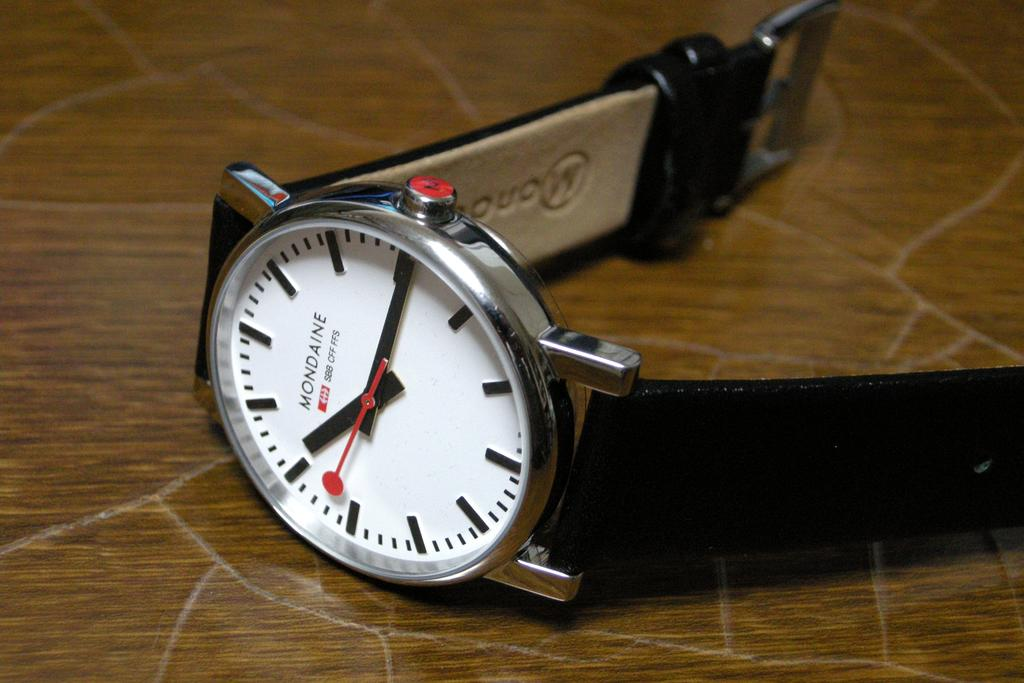<image>
Relay a brief, clear account of the picture shown. A Mondaine watch laying on its side on a surface. 